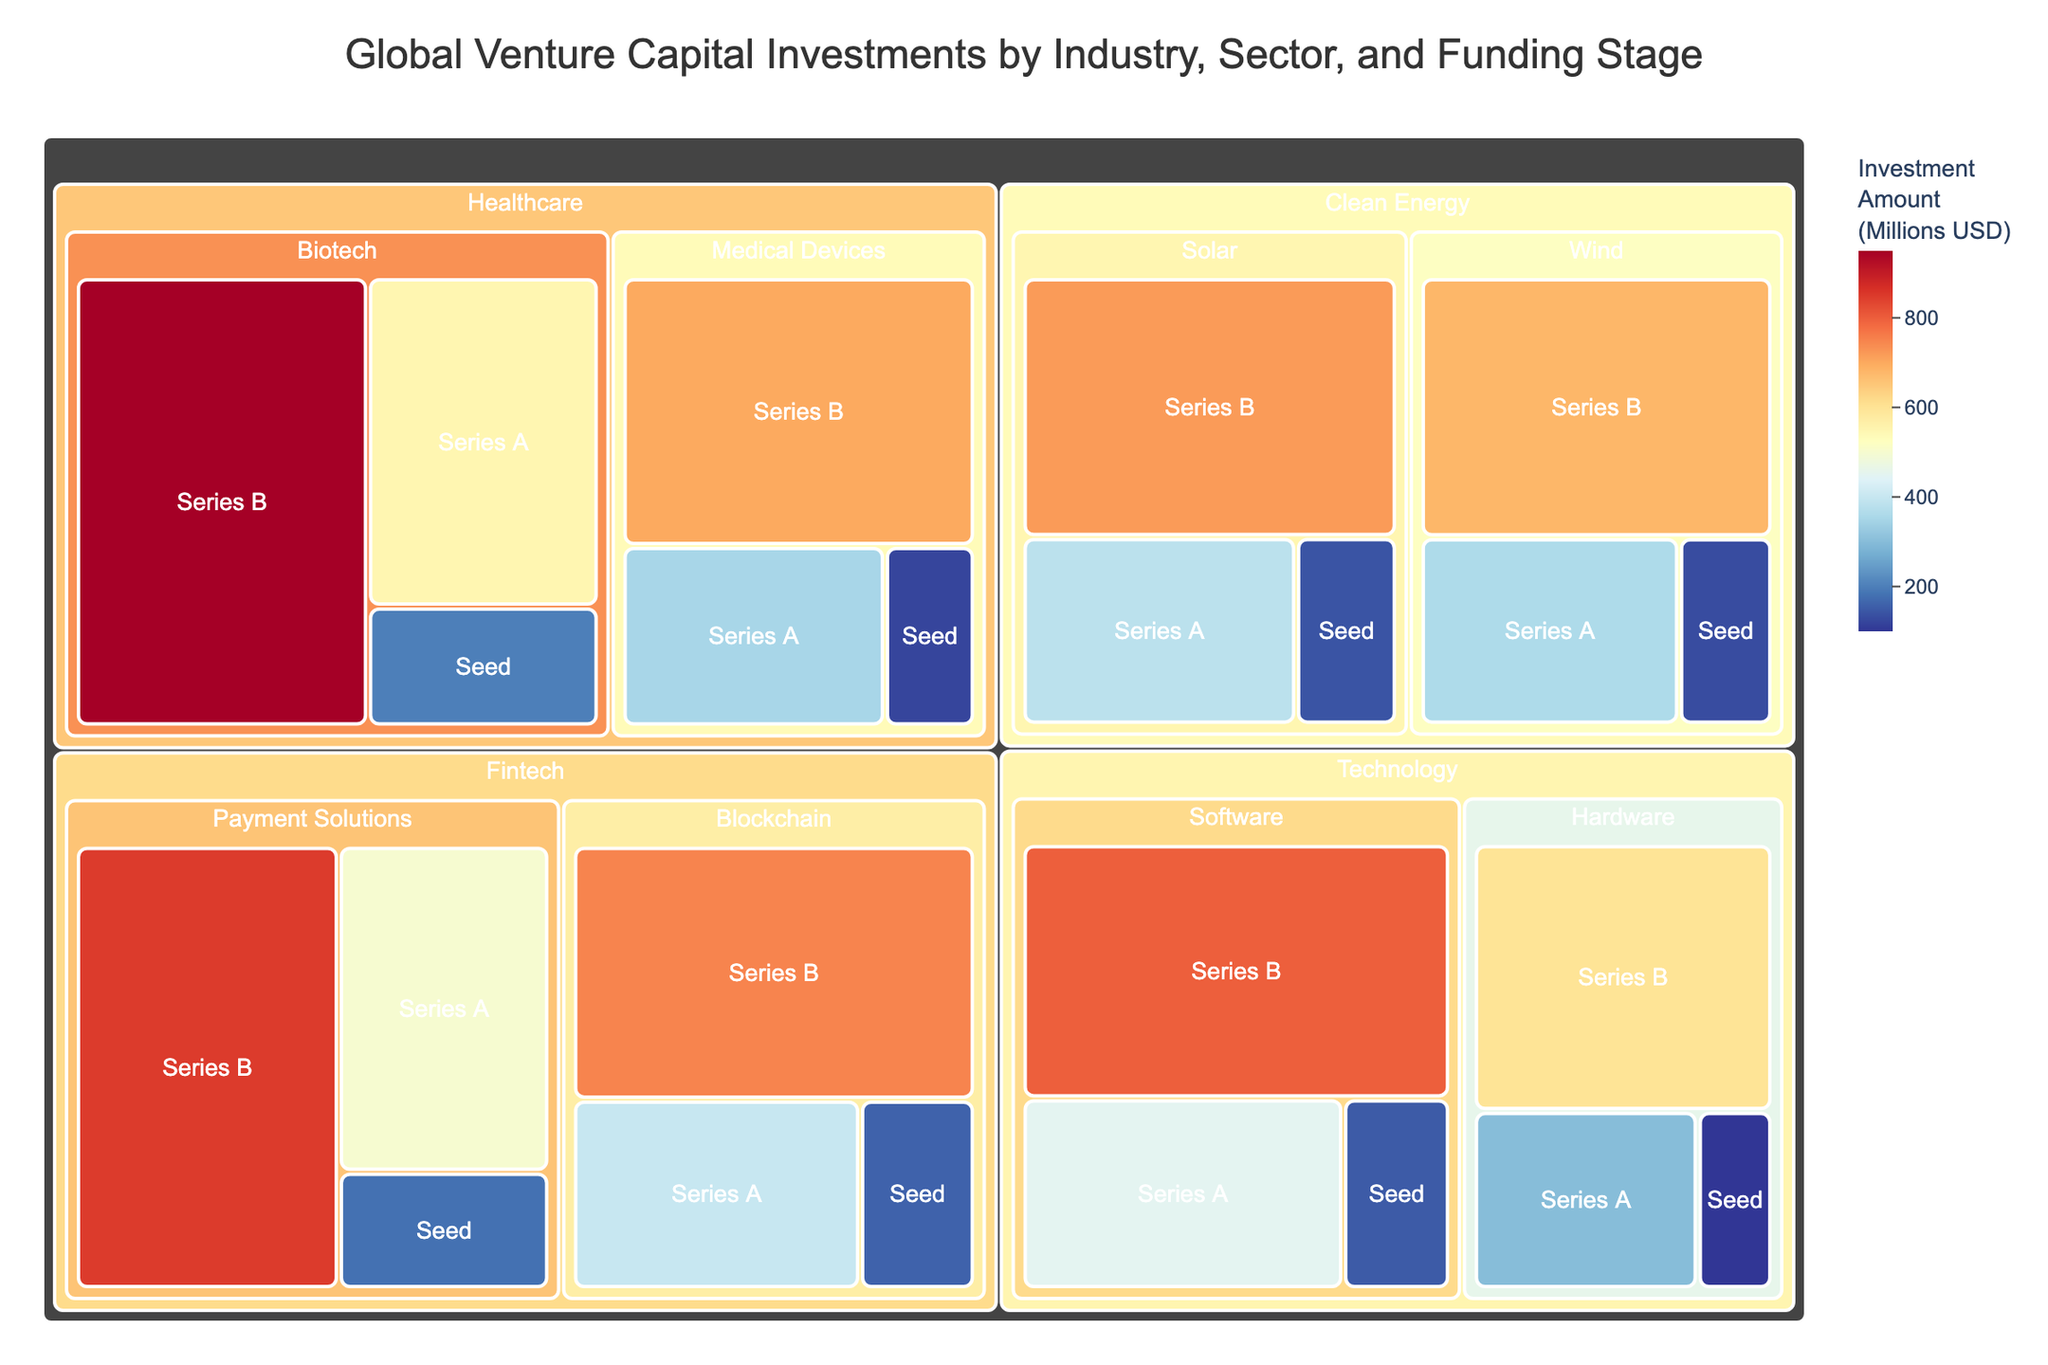what is the total investment amount at the Seed stage in the Healthcare sector? To find the total Healthcare investments at the Seed stage, sum up the investment amounts for Biotech and Medical Devices at the Seed stage: $200M (Biotech) + $120M (Medical Devices) = $320M
Answer: $320M Which sector received the highest Series A investment in the Fintech industry? Compare the Series A investment amounts in Payment Solutions and Blockchain within the Fintech industry: $500M (Payment Solutions) vs. $400M (Blockchain). Payment Solutions received the highest Series A investment.
Answer: Payment Solutions What is the difference in Series B investment between the Software and Hardware sectors in the Technology industry? Calculate the difference in Series B investments for Software and Hardware: $800M (Software) - $600M (Hardware) = $200M
Answer: $200M Which industry has the highest total investment amount? Sum the total investments for each industry and compare them: Technology (various sums), Healthcare (various sums), Fintech (various sums), Clean Energy (various sums). Technology has the highest total investment.
Answer: Technology How many unique sectors are visualized in the Clean Energy industry? Count the number of unique sectors displayed under the Clean Energy industry in the treemap: Solar, Wind.
Answer: 2 Which Funding Stage has the smallest investment amount in the Biotech sector of Healthcare? Compare the investment amounts at each Funding Stage within the Biotech sector: Seed ($200M), Series A ($550M), Series B ($950M). The Seed stage has the smallest investment.
Answer: Seed What's the total amount invested in the Series B stage across all sectors? Sum up all the Series B investments across sectors and industries: $800M (Software) + $600M (Hardware) + $950M (Biotech) + $700M (Medical Devices) + $850M (Payment Solutions) + $750M (Blockchain) + $720M (Solar) + $680M (Wind) = $6,050M
Answer: $6,050M Which industry has the most diversified sectors based on the treemap? Count the unique sectors in each industry to determine which has the highest number: Technology (Software, Hardware), Healthcare (Biotech, Medical Devices), Fintech (Payment Solutions, Blockchain), Clean Energy (Solar, Wind). If we look at the number of sectors, Technology and the rest have equal numbers according to this data.
Answer: Technology, Healthcare, Fintech, Clean Energy (tie) What is the average investment amount at the Series A stage for all sectors in the Clean Energy industry? Sum the Series A investment amounts in the Solar and Wind sectors, then divide by the number of sectors: ($380M + $360M) / 2 = $370M
Answer: $370M Which industry has the highest Seed investment total? Sum the Seed stage investments for each industry: Technology ($100M Hardware + $150M Software), Healthcare ($200M Biotech + $120M Medical Devices), Fintech ($180M Payment Solutions + $160M Blockchain), Clean Energy ($140M Solar + $130M Wind). Healthcare has the highest Seed investment sum.
Answer: Healthcare 